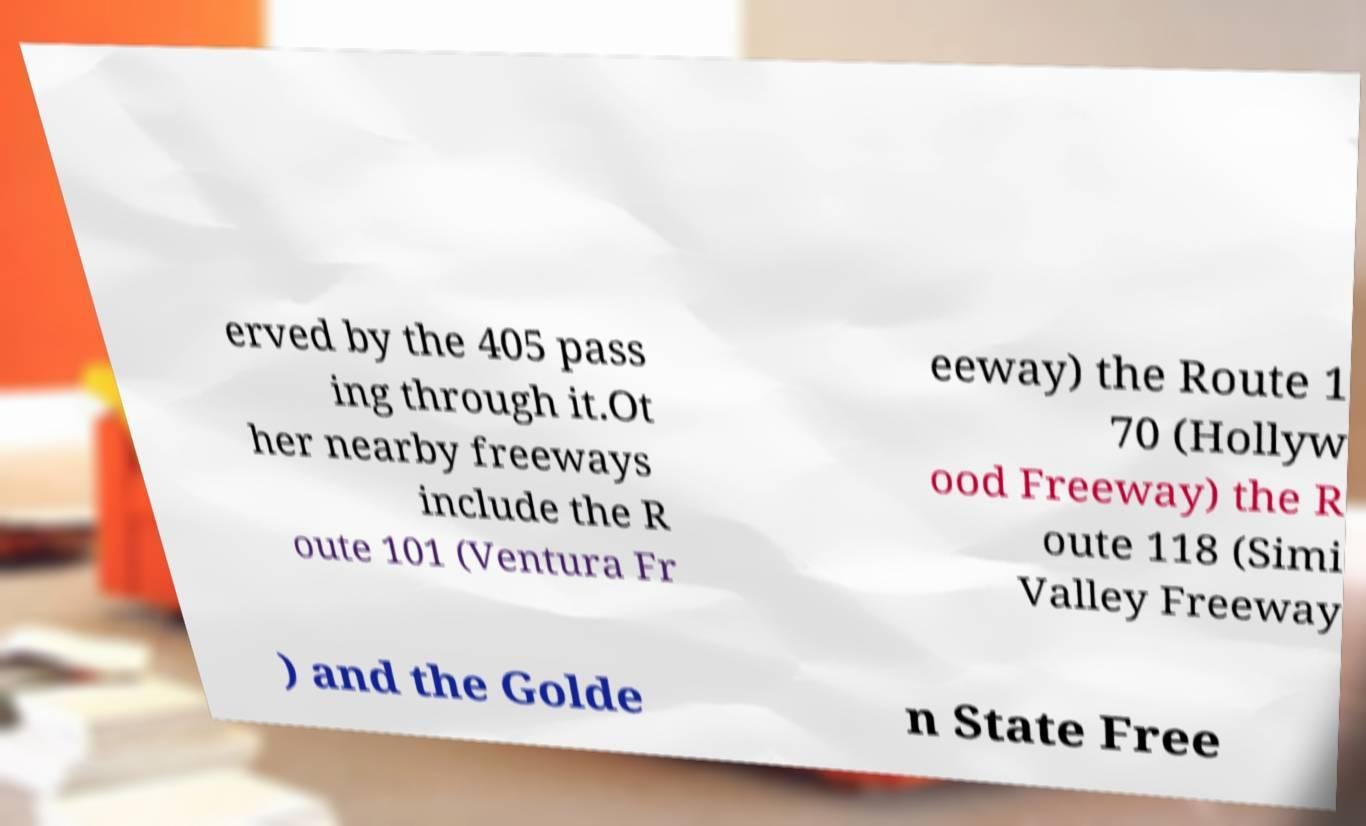Can you accurately transcribe the text from the provided image for me? erved by the 405 pass ing through it.Ot her nearby freeways include the R oute 101 (Ventura Fr eeway) the Route 1 70 (Hollyw ood Freeway) the R oute 118 (Simi Valley Freeway ) and the Golde n State Free 